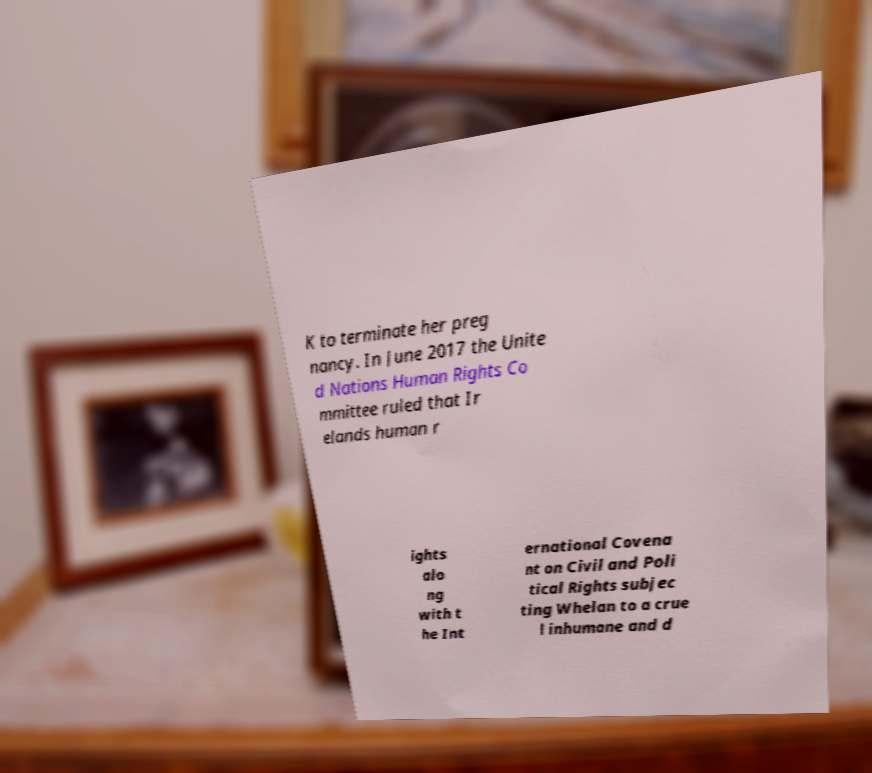Can you accurately transcribe the text from the provided image for me? K to terminate her preg nancy. In June 2017 the Unite d Nations Human Rights Co mmittee ruled that Ir elands human r ights alo ng with t he Int ernational Covena nt on Civil and Poli tical Rights subjec ting Whelan to a crue l inhumane and d 